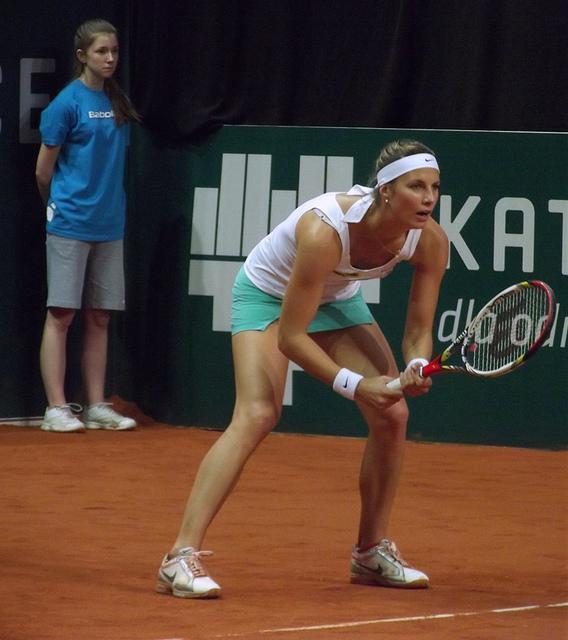What is she ready to do?
Make your selection from the four choices given to correctly answer the question.
Options: Swing, sit, swim, eat. Swing. 